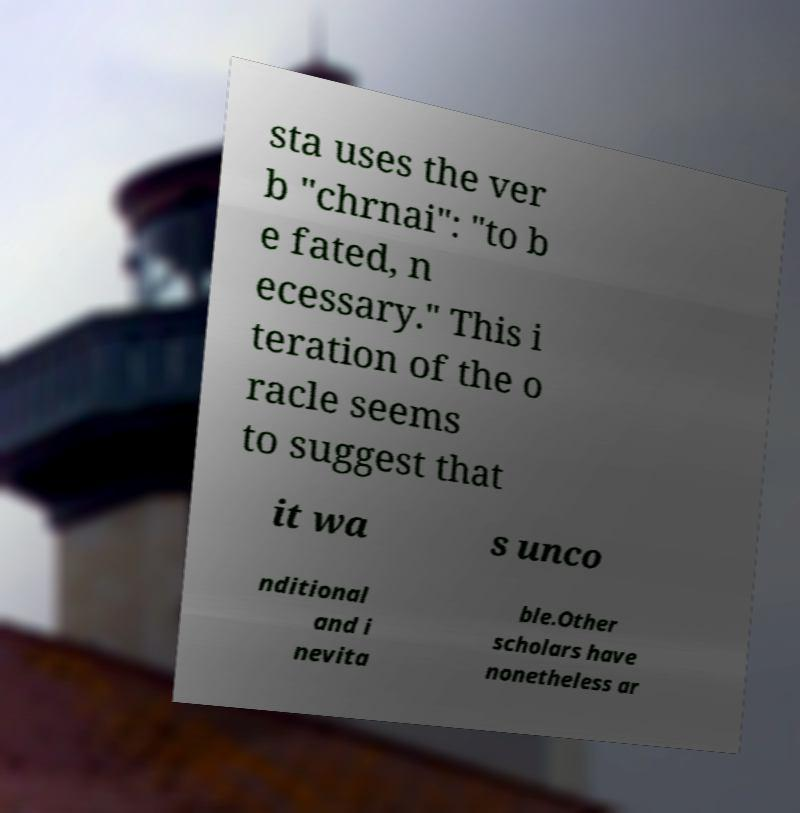Can you read and provide the text displayed in the image?This photo seems to have some interesting text. Can you extract and type it out for me? sta uses the ver b "chrnai": "to b e fated, n ecessary." This i teration of the o racle seems to suggest that it wa s unco nditional and i nevita ble.Other scholars have nonetheless ar 